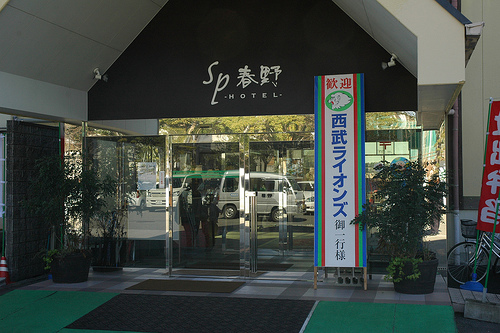<image>
Can you confirm if the car is in front of the sign? No. The car is not in front of the sign. The spatial positioning shows a different relationship between these objects. 